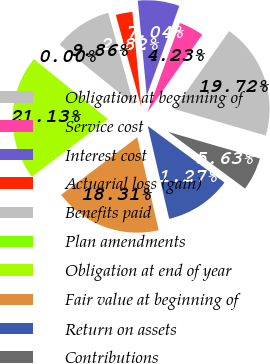Convert chart to OTSL. <chart><loc_0><loc_0><loc_500><loc_500><pie_chart><fcel>Obligation at beginning of<fcel>Service cost<fcel>Interest cost<fcel>Actuarial loss (gain)<fcel>Benefits paid<fcel>Plan amendments<fcel>Obligation at end of year<fcel>Fair value at beginning of<fcel>Return on assets<fcel>Contributions<nl><fcel>19.72%<fcel>4.23%<fcel>7.04%<fcel>2.82%<fcel>9.86%<fcel>0.0%<fcel>21.13%<fcel>18.31%<fcel>11.27%<fcel>5.63%<nl></chart> 